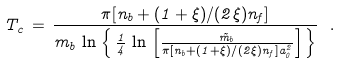Convert formula to latex. <formula><loc_0><loc_0><loc_500><loc_500>T _ { c } \, = \, \frac { \pi [ n _ { b } + ( 1 + \xi ) / ( 2 \xi ) n _ { f } ] } { m _ { b } \, \ln { \, \left \{ \, \frac { 1 } { 4 } \, \ln { \, \left [ \frac { \tilde { m } _ { b } } { \pi [ n _ { b } + ( 1 + \xi ) / ( 2 \xi ) n _ { f } ] a _ { 0 } ^ { 2 } } \right ] } \, \right \} } } \ .</formula> 